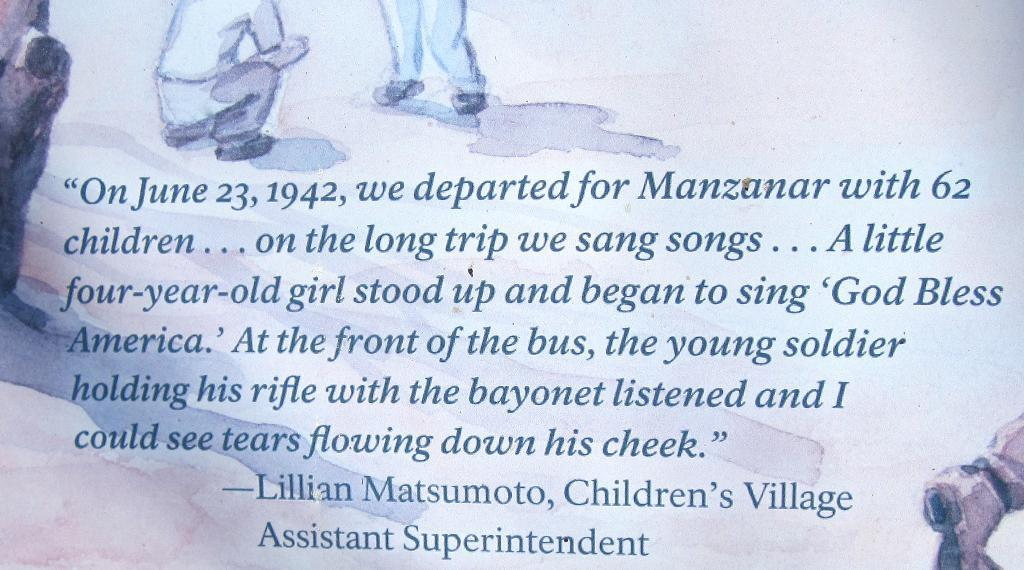What is written or mentioned on a surface in the image? There is a quotation mentioned on a surface in the image. What else can be seen around the quotation in the image? There are paintings of people around the quotation in the image. What type of kite is being flown by the pet in the image? There is no kite or pet present in the image; it features a quotation and paintings of people. 